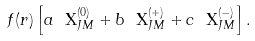Convert formula to latex. <formula><loc_0><loc_0><loc_500><loc_500>f ( r ) \left [ a \ { \mathbf X } ^ { ( 0 ) } _ { J M } + b \ { \mathbf X } ^ { ( + ) } _ { J M } + c \ { \mathbf X } ^ { ( - ) } _ { J M } \right ] .</formula> 